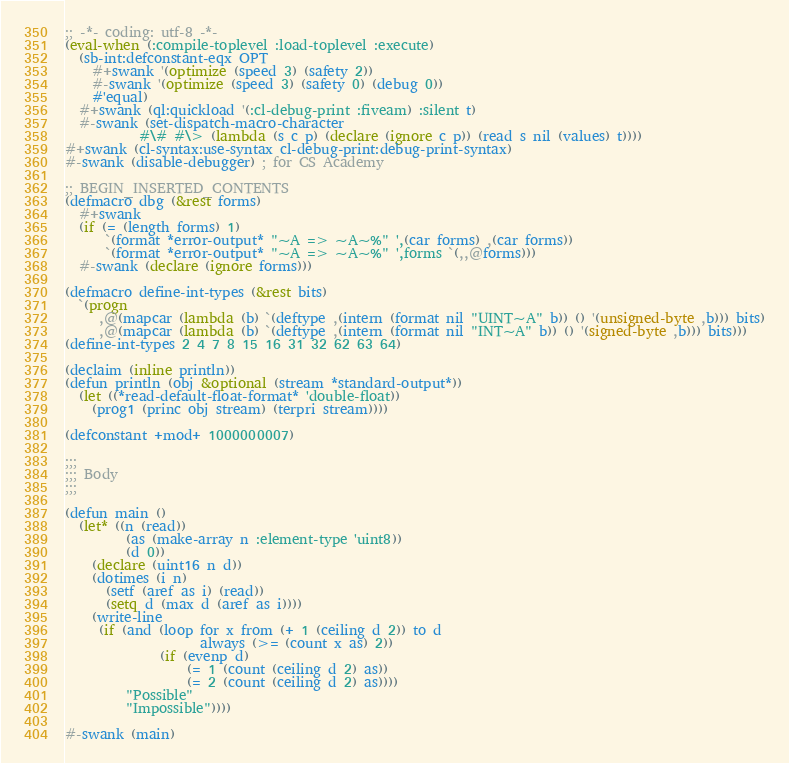<code> <loc_0><loc_0><loc_500><loc_500><_Lisp_>;; -*- coding: utf-8 -*-
(eval-when (:compile-toplevel :load-toplevel :execute)
  (sb-int:defconstant-eqx OPT
    #+swank '(optimize (speed 3) (safety 2))
    #-swank '(optimize (speed 3) (safety 0) (debug 0))
    #'equal)
  #+swank (ql:quickload '(:cl-debug-print :fiveam) :silent t)
  #-swank (set-dispatch-macro-character
           #\# #\> (lambda (s c p) (declare (ignore c p)) (read s nil (values) t))))
#+swank (cl-syntax:use-syntax cl-debug-print:debug-print-syntax)
#-swank (disable-debugger) ; for CS Academy

;; BEGIN_INSERTED_CONTENTS
(defmacro dbg (&rest forms)
  #+swank
  (if (= (length forms) 1)
      `(format *error-output* "~A => ~A~%" ',(car forms) ,(car forms))
      `(format *error-output* "~A => ~A~%" ',forms `(,,@forms)))
  #-swank (declare (ignore forms)))

(defmacro define-int-types (&rest bits)
  `(progn
     ,@(mapcar (lambda (b) `(deftype ,(intern (format nil "UINT~A" b)) () '(unsigned-byte ,b))) bits)
     ,@(mapcar (lambda (b) `(deftype ,(intern (format nil "INT~A" b)) () '(signed-byte ,b))) bits)))
(define-int-types 2 4 7 8 15 16 31 32 62 63 64)

(declaim (inline println))
(defun println (obj &optional (stream *standard-output*))
  (let ((*read-default-float-format* 'double-float))
    (prog1 (princ obj stream) (terpri stream))))

(defconstant +mod+ 1000000007)

;;;
;;; Body
;;;

(defun main ()
  (let* ((n (read))
         (as (make-array n :element-type 'uint8))
         (d 0))
    (declare (uint16 n d))
    (dotimes (i n)
      (setf (aref as i) (read))
      (setq d (max d (aref as i))))
    (write-line
     (if (and (loop for x from (+ 1 (ceiling d 2)) to d
                    always (>= (count x as) 2))
              (if (evenp d)
                  (= 1 (count (ceiling d 2) as))
                  (= 2 (count (ceiling d 2) as))))
         "Possible"
         "Impossible"))))

#-swank (main)
</code> 